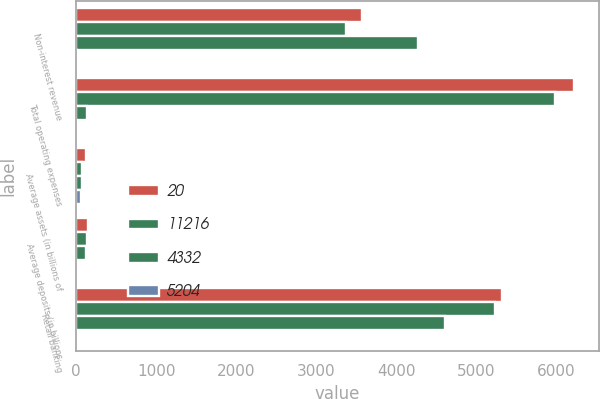<chart> <loc_0><loc_0><loc_500><loc_500><stacked_bar_chart><ecel><fcel>Non-interest revenue<fcel>Total operating expenses<fcel>Average assets (in billions of<fcel>Average deposits (in billions<fcel>Retail banking<nl><fcel>20<fcel>3574<fcel>6224<fcel>119<fcel>145<fcel>5325<nl><fcel>11216<fcel>3372<fcel>5987<fcel>73<fcel>140<fcel>5237<nl><fcel>4332<fcel>4275<fcel>140<fcel>75<fcel>125<fcel>4613<nl><fcel>5204<fcel>6<fcel>4<fcel>63<fcel>4<fcel>2<nl></chart> 